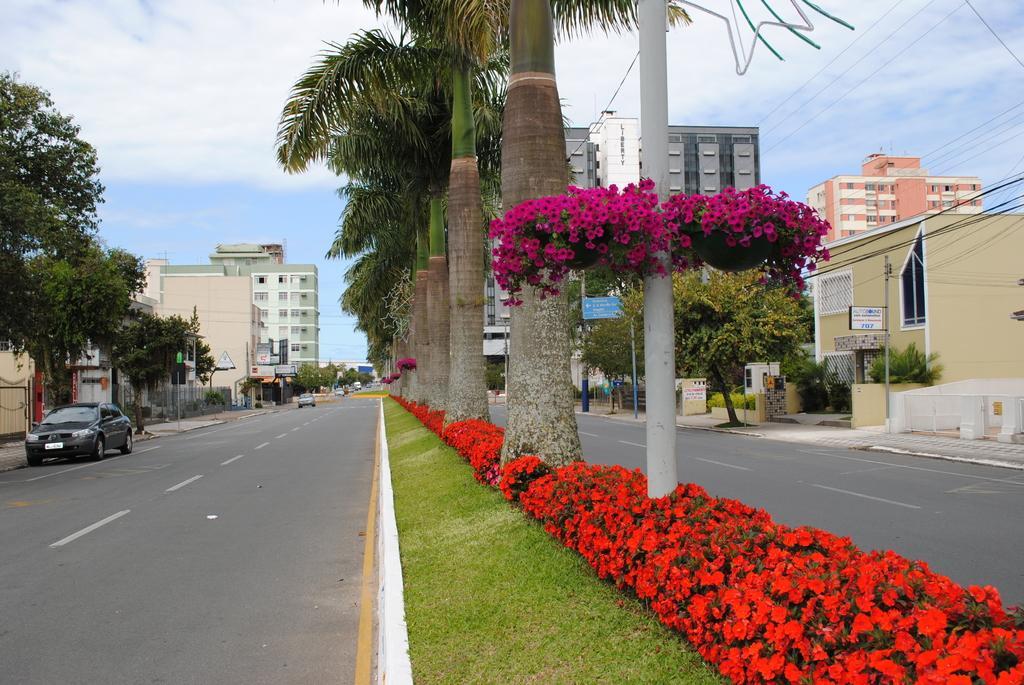Please provide a concise description of this image. In this picture we can see some grass and a few red flowers on the path. There are pink flowers around a pole. We can see a few plants on the path. There are vehicles on the road. We can see some boards on the poles, trees and wires on top. Sky is blue in color and cloudy. 